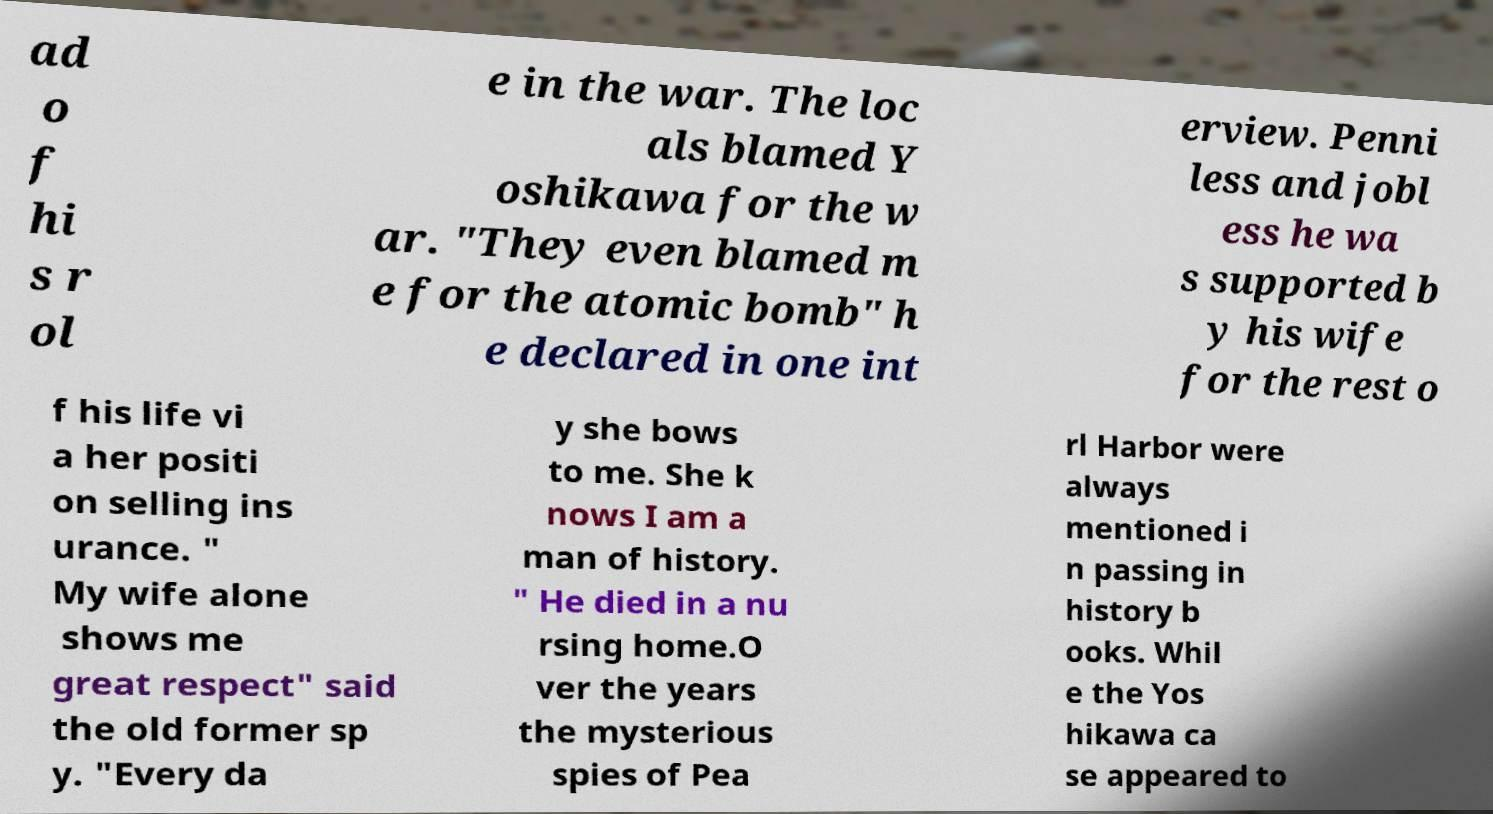For documentation purposes, I need the text within this image transcribed. Could you provide that? ad o f hi s r ol e in the war. The loc als blamed Y oshikawa for the w ar. "They even blamed m e for the atomic bomb" h e declared in one int erview. Penni less and jobl ess he wa s supported b y his wife for the rest o f his life vi a her positi on selling ins urance. " My wife alone shows me great respect" said the old former sp y. "Every da y she bows to me. She k nows I am a man of history. " He died in a nu rsing home.O ver the years the mysterious spies of Pea rl Harbor were always mentioned i n passing in history b ooks. Whil e the Yos hikawa ca se appeared to 